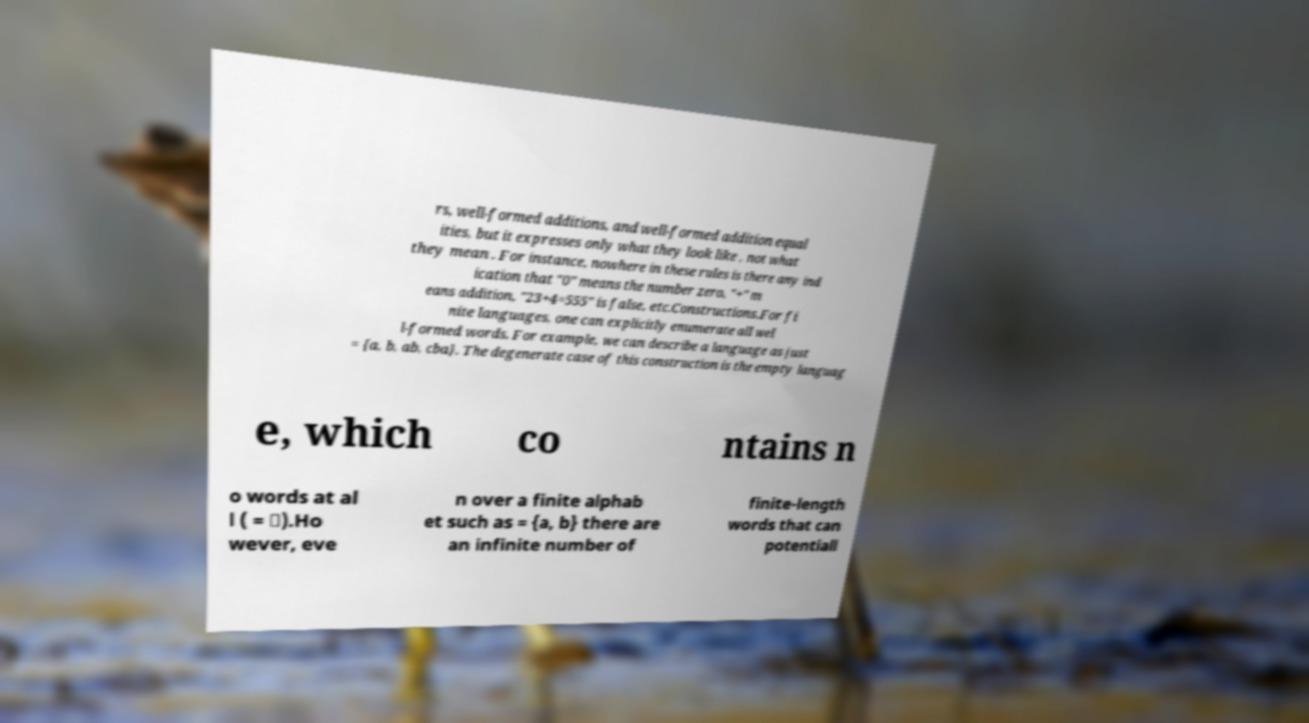Please identify and transcribe the text found in this image. rs, well-formed additions, and well-formed addition equal ities, but it expresses only what they look like , not what they mean . For instance, nowhere in these rules is there any ind ication that "0" means the number zero, "+" m eans addition, "23+4=555" is false, etc.Constructions.For fi nite languages, one can explicitly enumerate all wel l-formed words. For example, we can describe a language as just = {a, b, ab, cba}. The degenerate case of this construction is the empty languag e, which co ntains n o words at al l ( = ∅).Ho wever, eve n over a finite alphab et such as = {a, b} there are an infinite number of finite-length words that can potentiall 